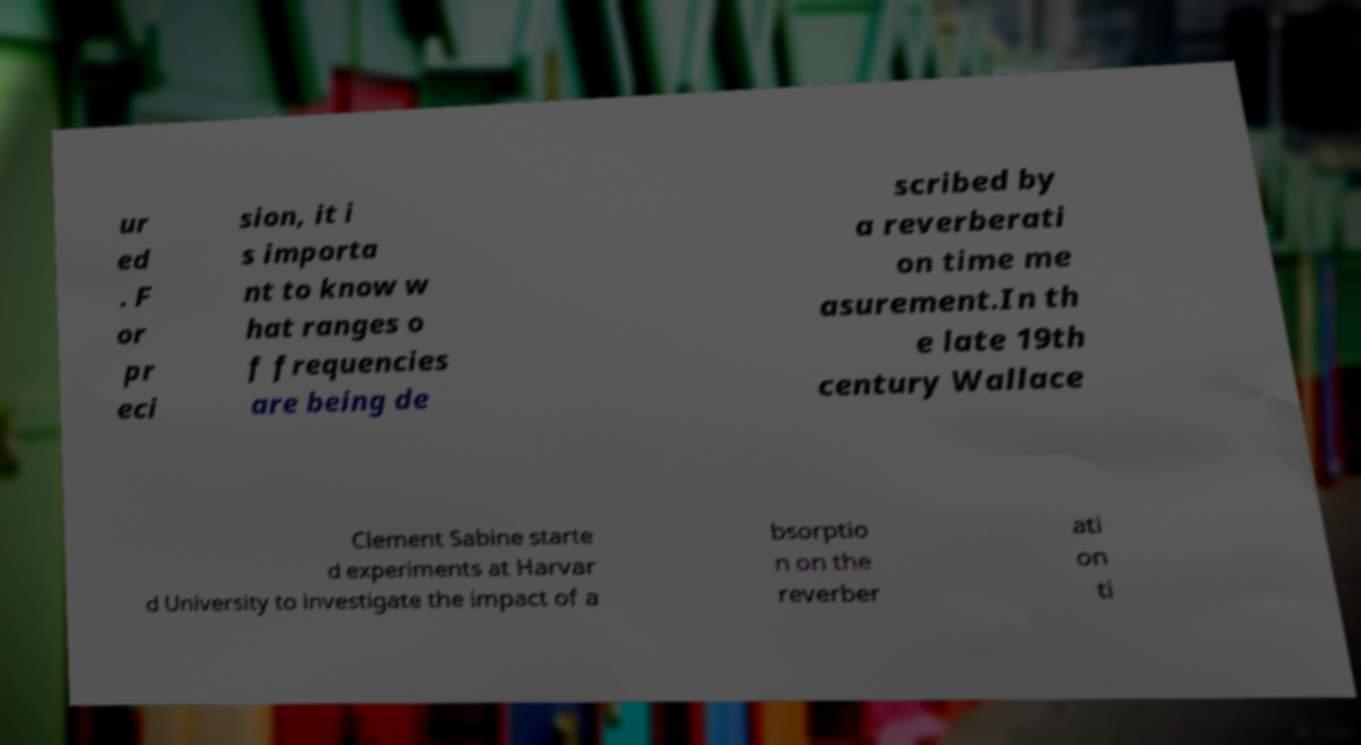Can you accurately transcribe the text from the provided image for me? ur ed . F or pr eci sion, it i s importa nt to know w hat ranges o f frequencies are being de scribed by a reverberati on time me asurement.In th e late 19th century Wallace Clement Sabine starte d experiments at Harvar d University to investigate the impact of a bsorptio n on the reverber ati on ti 